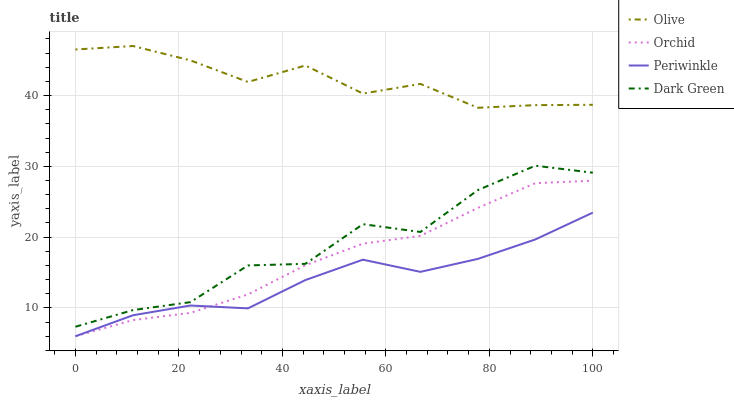Does Dark Green have the minimum area under the curve?
Answer yes or no. No. Does Dark Green have the maximum area under the curve?
Answer yes or no. No. Is Periwinkle the smoothest?
Answer yes or no. No. Is Periwinkle the roughest?
Answer yes or no. No. Does Dark Green have the lowest value?
Answer yes or no. No. Does Dark Green have the highest value?
Answer yes or no. No. Is Periwinkle less than Olive?
Answer yes or no. Yes. Is Olive greater than Dark Green?
Answer yes or no. Yes. Does Periwinkle intersect Olive?
Answer yes or no. No. 